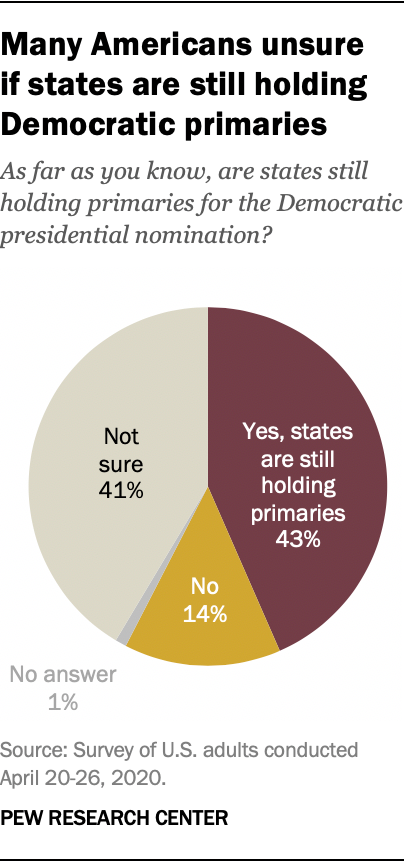Specify some key components in this picture. The data shows that a larger percentage of people said "yes" than "no." Specifically, the difference between the two responses was 0.29%. The graph shows that 0.14% of people answered "No" to the question. 